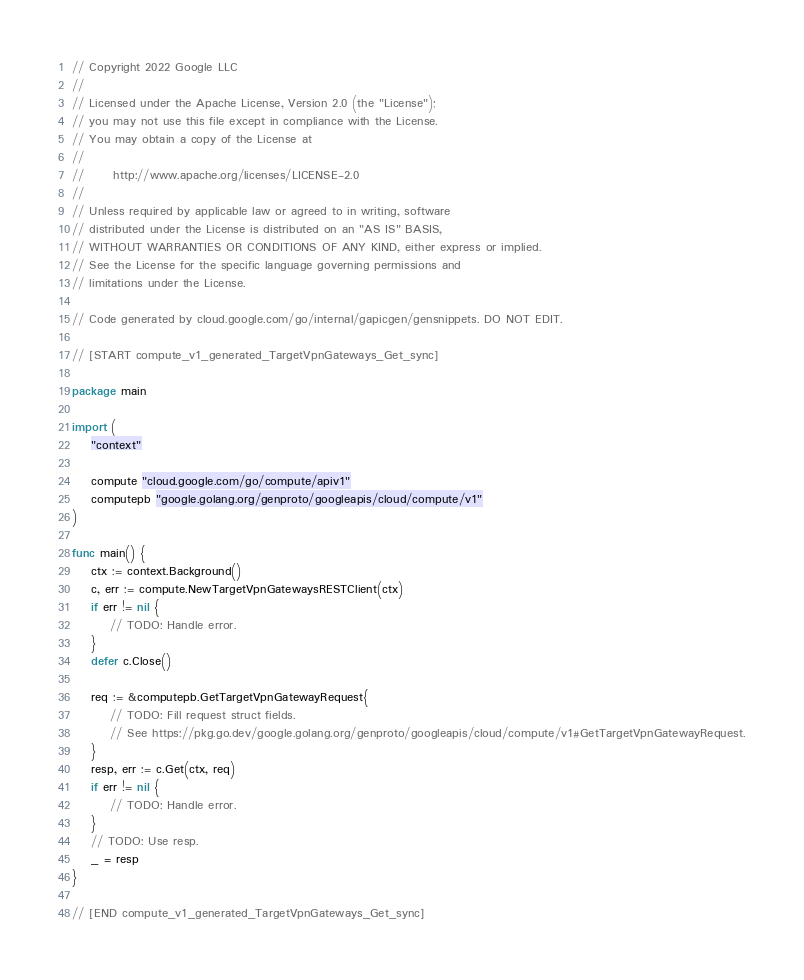<code> <loc_0><loc_0><loc_500><loc_500><_Go_>// Copyright 2022 Google LLC
//
// Licensed under the Apache License, Version 2.0 (the "License");
// you may not use this file except in compliance with the License.
// You may obtain a copy of the License at
//
//      http://www.apache.org/licenses/LICENSE-2.0
//
// Unless required by applicable law or agreed to in writing, software
// distributed under the License is distributed on an "AS IS" BASIS,
// WITHOUT WARRANTIES OR CONDITIONS OF ANY KIND, either express or implied.
// See the License for the specific language governing permissions and
// limitations under the License.

// Code generated by cloud.google.com/go/internal/gapicgen/gensnippets. DO NOT EDIT.

// [START compute_v1_generated_TargetVpnGateways_Get_sync]

package main

import (
	"context"

	compute "cloud.google.com/go/compute/apiv1"
	computepb "google.golang.org/genproto/googleapis/cloud/compute/v1"
)

func main() {
	ctx := context.Background()
	c, err := compute.NewTargetVpnGatewaysRESTClient(ctx)
	if err != nil {
		// TODO: Handle error.
	}
	defer c.Close()

	req := &computepb.GetTargetVpnGatewayRequest{
		// TODO: Fill request struct fields.
		// See https://pkg.go.dev/google.golang.org/genproto/googleapis/cloud/compute/v1#GetTargetVpnGatewayRequest.
	}
	resp, err := c.Get(ctx, req)
	if err != nil {
		// TODO: Handle error.
	}
	// TODO: Use resp.
	_ = resp
}

// [END compute_v1_generated_TargetVpnGateways_Get_sync]
</code> 